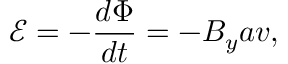<formula> <loc_0><loc_0><loc_500><loc_500>\mathcal { E } = - \frac { d \Phi } { d t } = - B _ { y } a v ,</formula> 